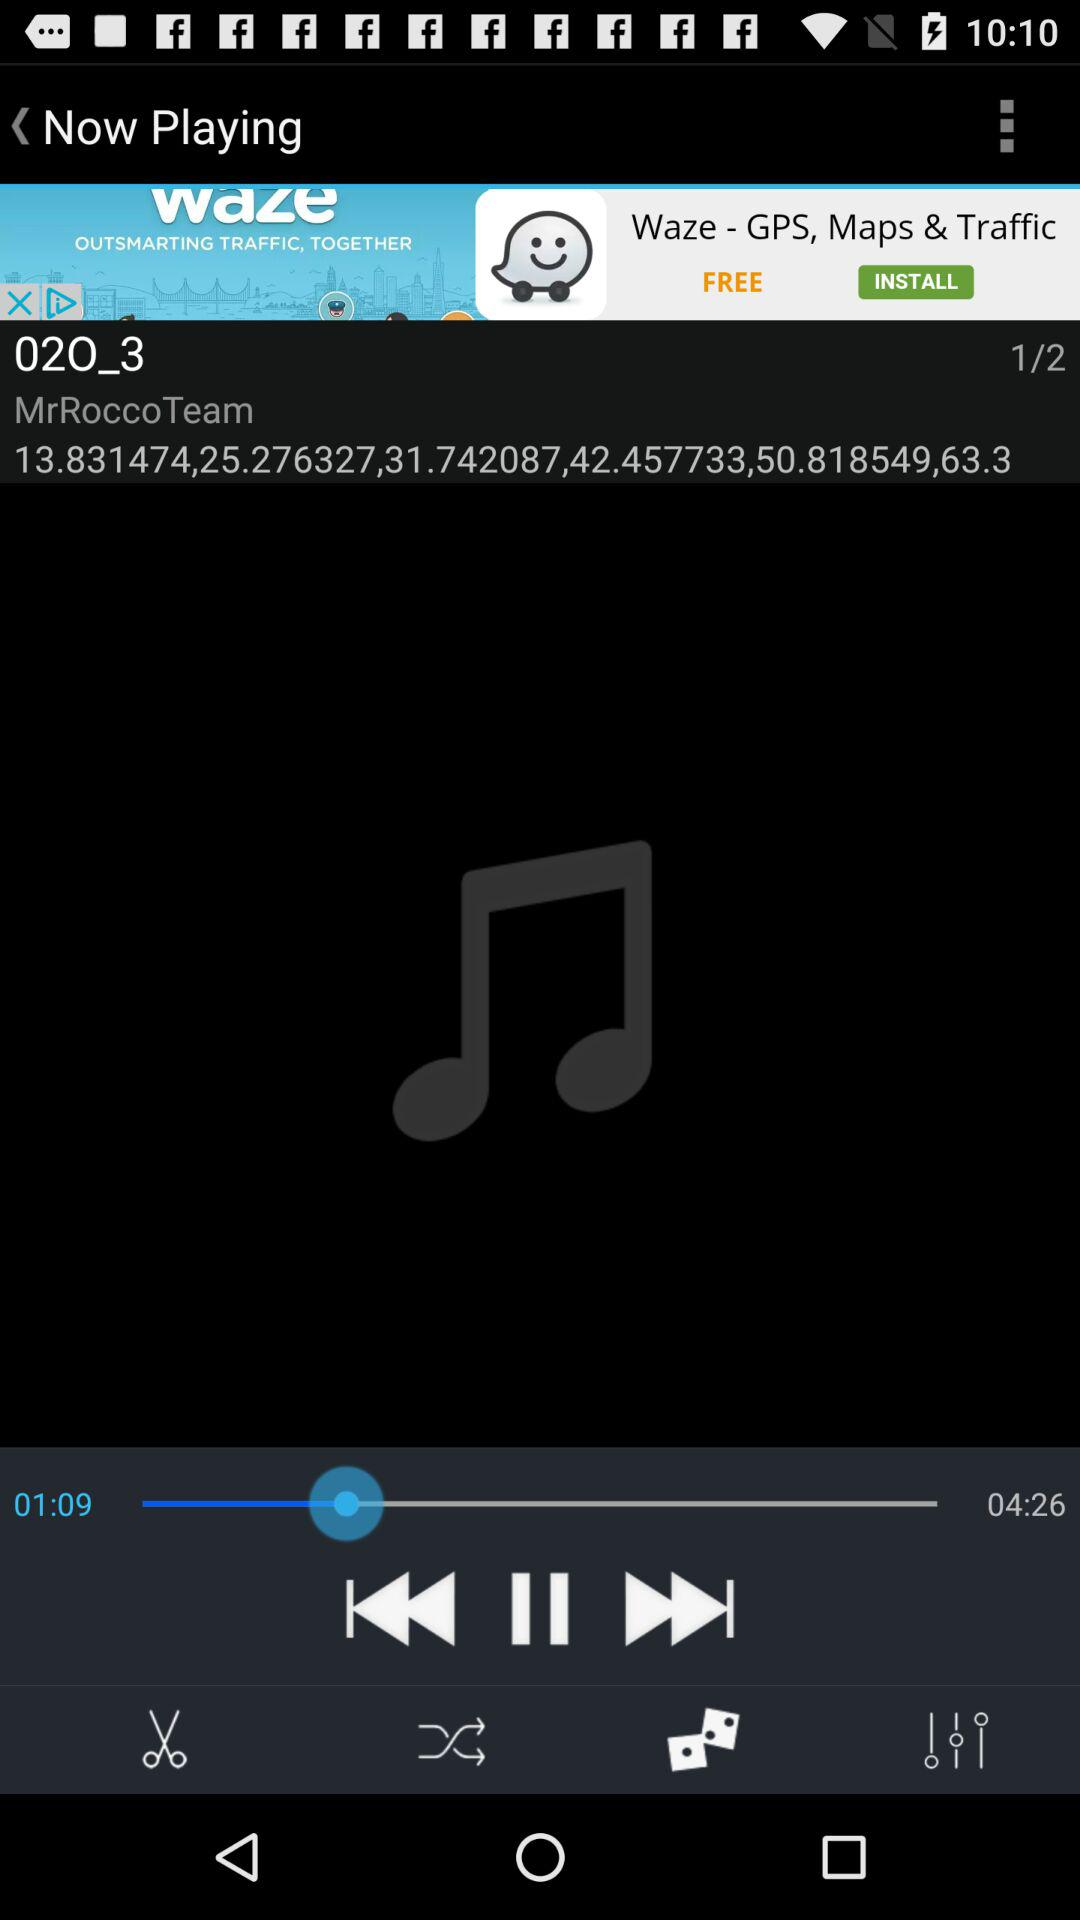What is the name of the audio being played? The name of the audio is "02O_3". 